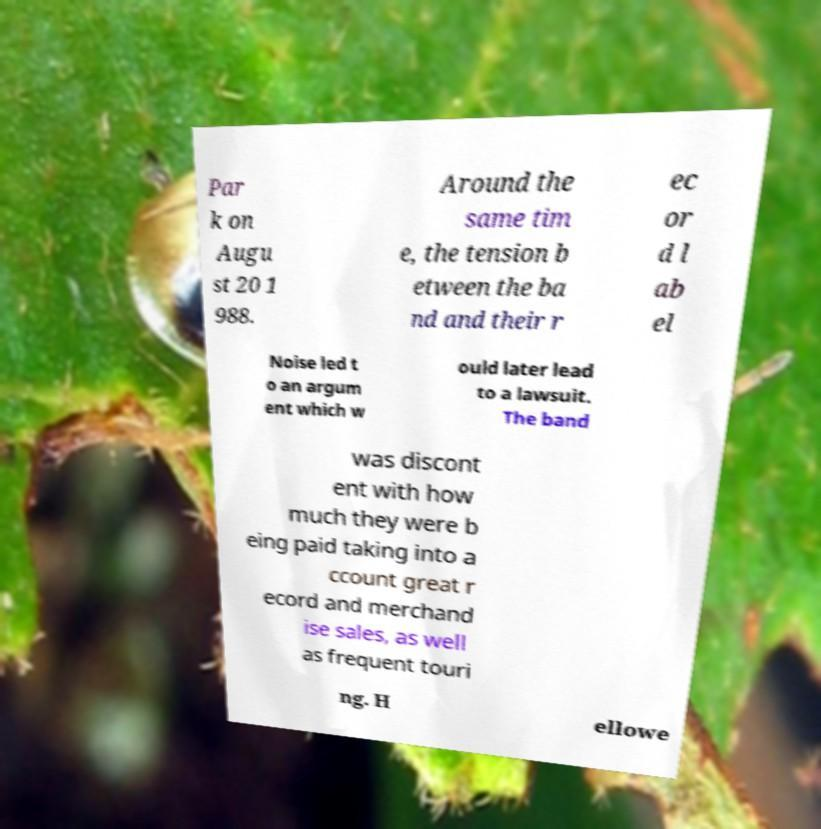Can you read and provide the text displayed in the image?This photo seems to have some interesting text. Can you extract and type it out for me? Par k on Augu st 20 1 988. Around the same tim e, the tension b etween the ba nd and their r ec or d l ab el Noise led t o an argum ent which w ould later lead to a lawsuit. The band was discont ent with how much they were b eing paid taking into a ccount great r ecord and merchand ise sales, as well as frequent touri ng. H ellowe 